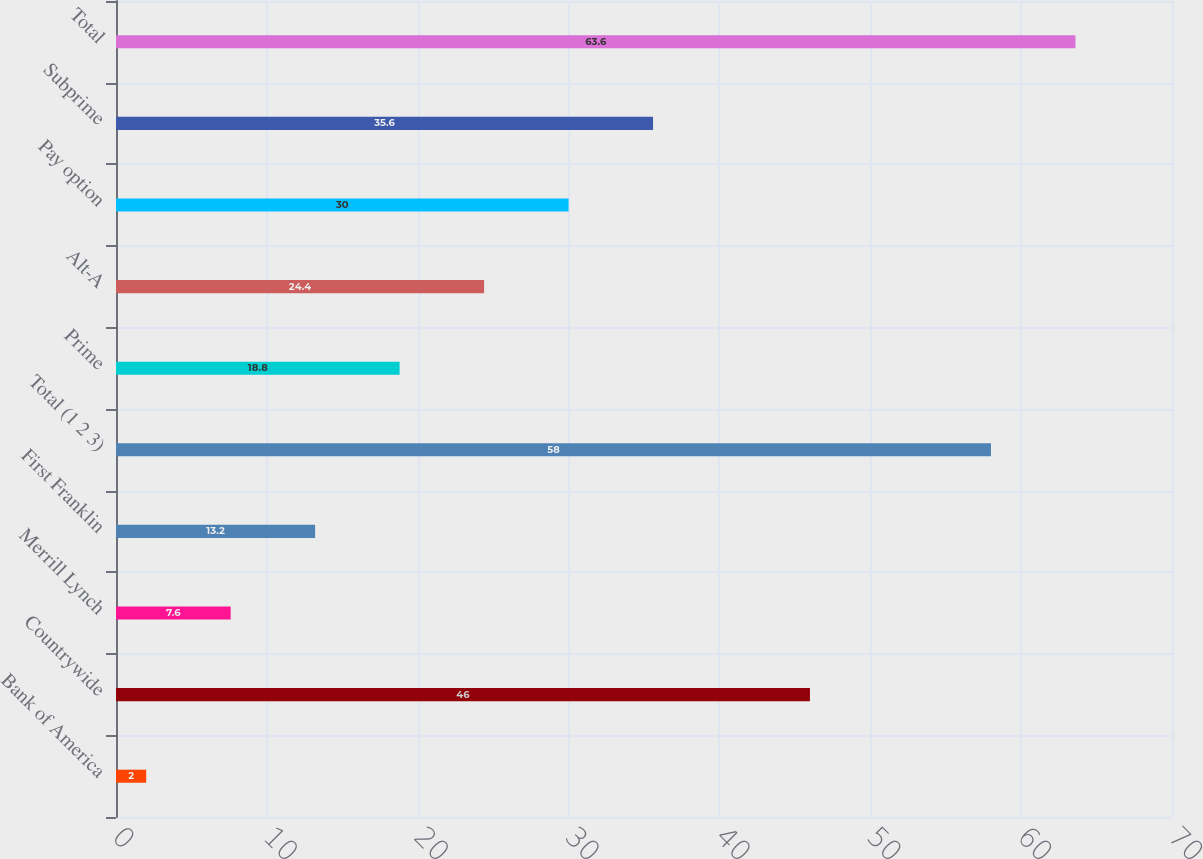Convert chart to OTSL. <chart><loc_0><loc_0><loc_500><loc_500><bar_chart><fcel>Bank of America<fcel>Countrywide<fcel>Merrill Lynch<fcel>First Franklin<fcel>Total (1 2 3)<fcel>Prime<fcel>Alt-A<fcel>Pay option<fcel>Subprime<fcel>Total<nl><fcel>2<fcel>46<fcel>7.6<fcel>13.2<fcel>58<fcel>18.8<fcel>24.4<fcel>30<fcel>35.6<fcel>63.6<nl></chart> 